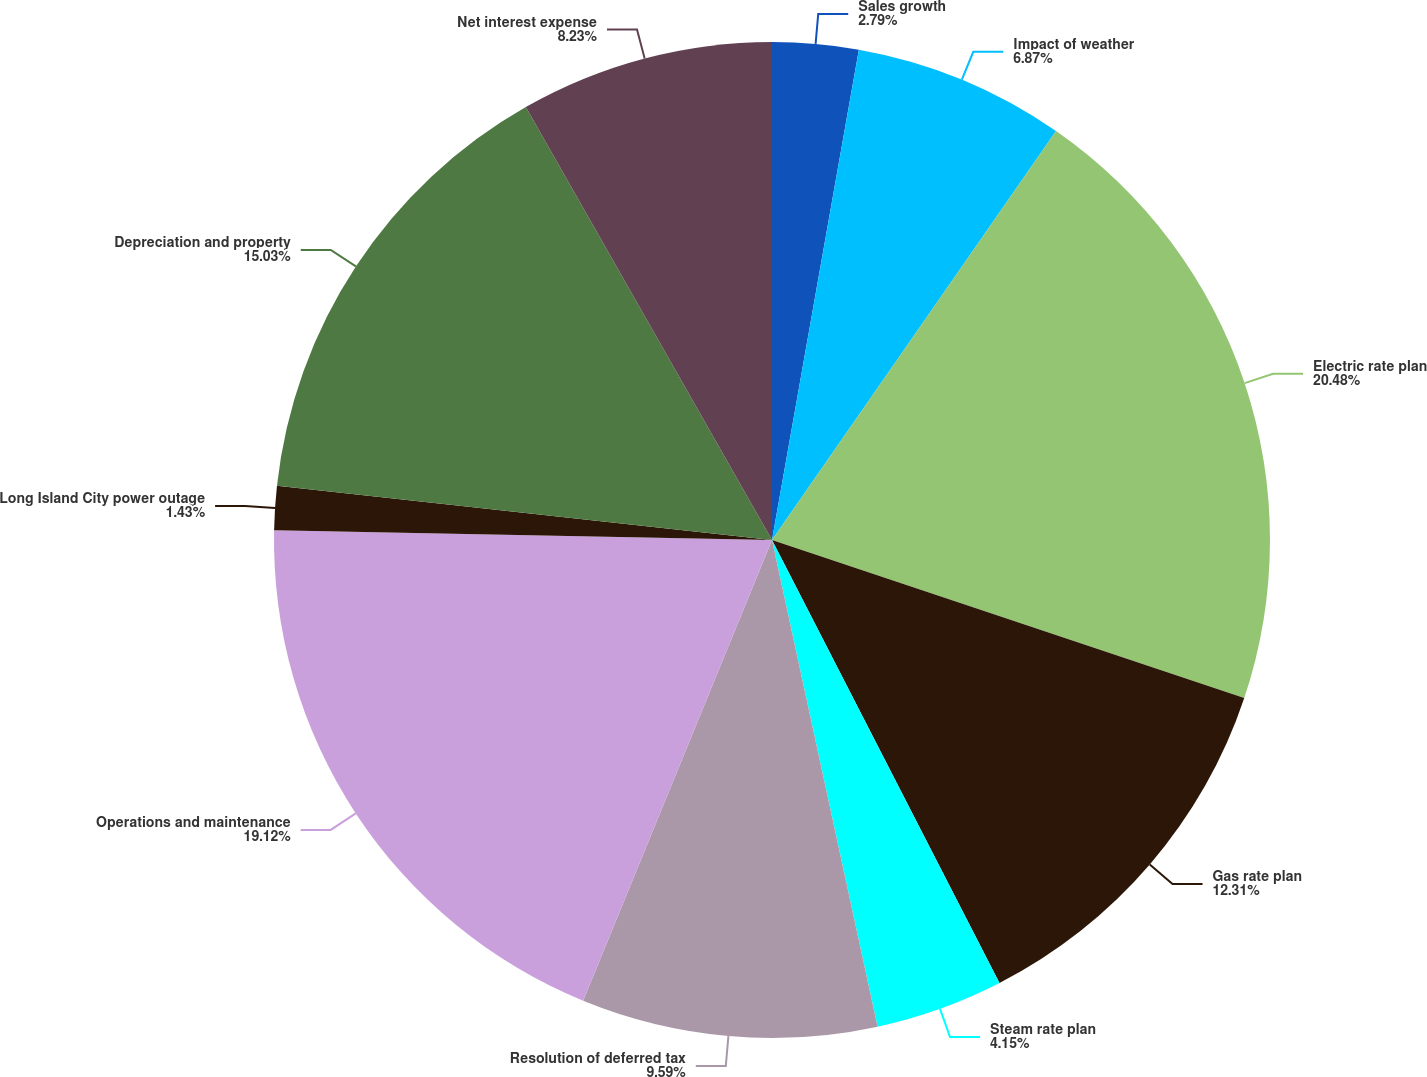Convert chart to OTSL. <chart><loc_0><loc_0><loc_500><loc_500><pie_chart><fcel>Sales growth<fcel>Impact of weather<fcel>Electric rate plan<fcel>Gas rate plan<fcel>Steam rate plan<fcel>Resolution of deferred tax<fcel>Operations and maintenance<fcel>Long Island City power outage<fcel>Depreciation and property<fcel>Net interest expense<nl><fcel>2.79%<fcel>6.87%<fcel>20.48%<fcel>12.31%<fcel>4.15%<fcel>9.59%<fcel>19.12%<fcel>1.43%<fcel>15.03%<fcel>8.23%<nl></chart> 